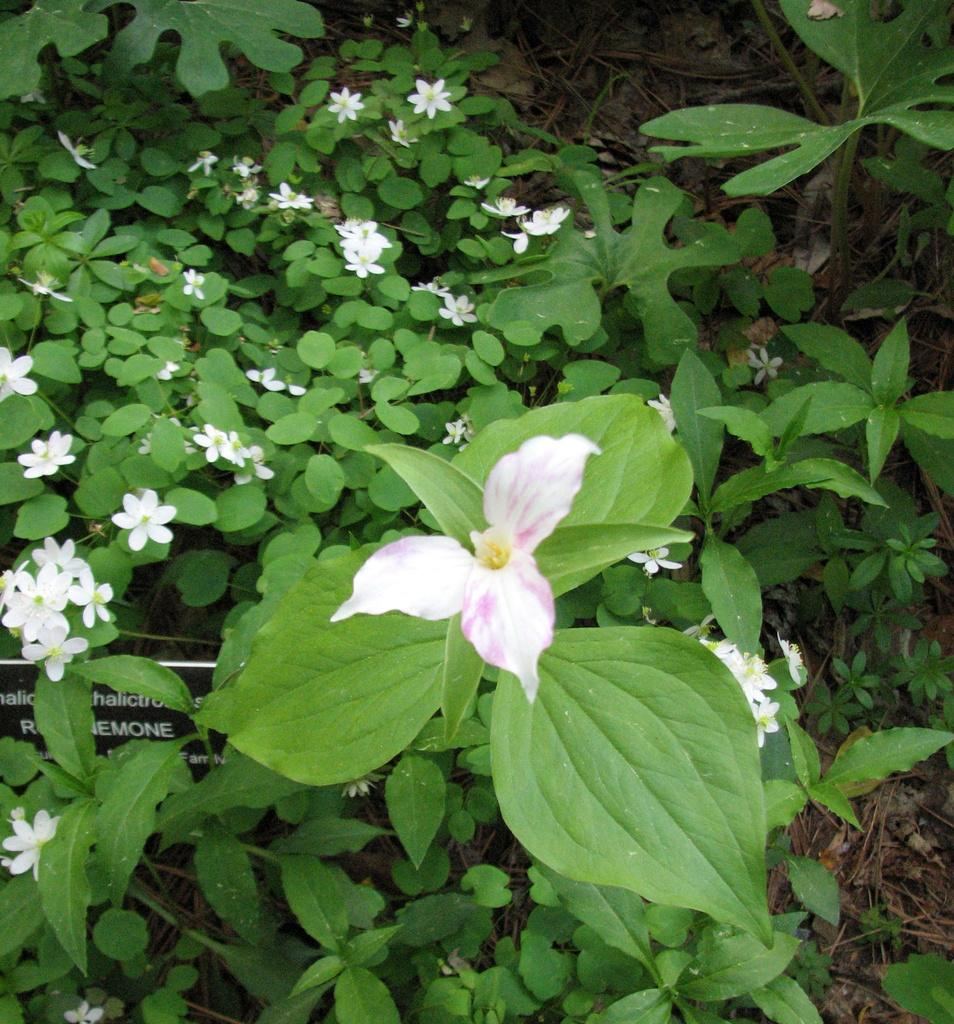What type of vegetation can be seen in the image? There are plants and flowers in the image. Can you describe the condition of the grass in the image? Dry grass is present in the image. How many twigs are being used to kiss the flowers in the image? There are no twigs or kissing depicted in the image; it features plants and flowers with dry grass. 